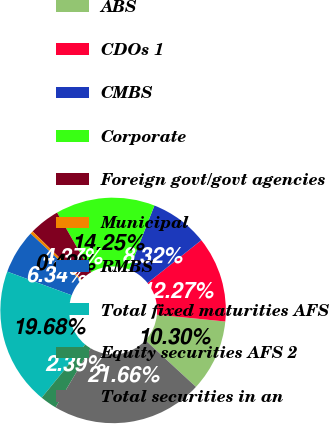Convert chart to OTSL. <chart><loc_0><loc_0><loc_500><loc_500><pie_chart><fcel>ABS<fcel>CDOs 1<fcel>CMBS<fcel>Corporate<fcel>Foreign govt/govt agencies<fcel>Municipal<fcel>RMBS<fcel>Total fixed maturities AFS<fcel>Equity securities AFS 2<fcel>Total securities in an<nl><fcel>10.3%<fcel>12.27%<fcel>8.32%<fcel>14.25%<fcel>4.37%<fcel>0.42%<fcel>6.34%<fcel>19.68%<fcel>2.39%<fcel>21.66%<nl></chart> 